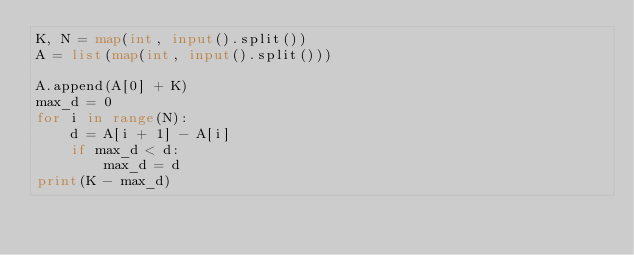Convert code to text. <code><loc_0><loc_0><loc_500><loc_500><_Python_>K, N = map(int, input().split())
A = list(map(int, input().split()))

A.append(A[0] + K)
max_d = 0
for i in range(N):
	d = A[i + 1] - A[i]
	if max_d < d:
		max_d = d
print(K - max_d)</code> 